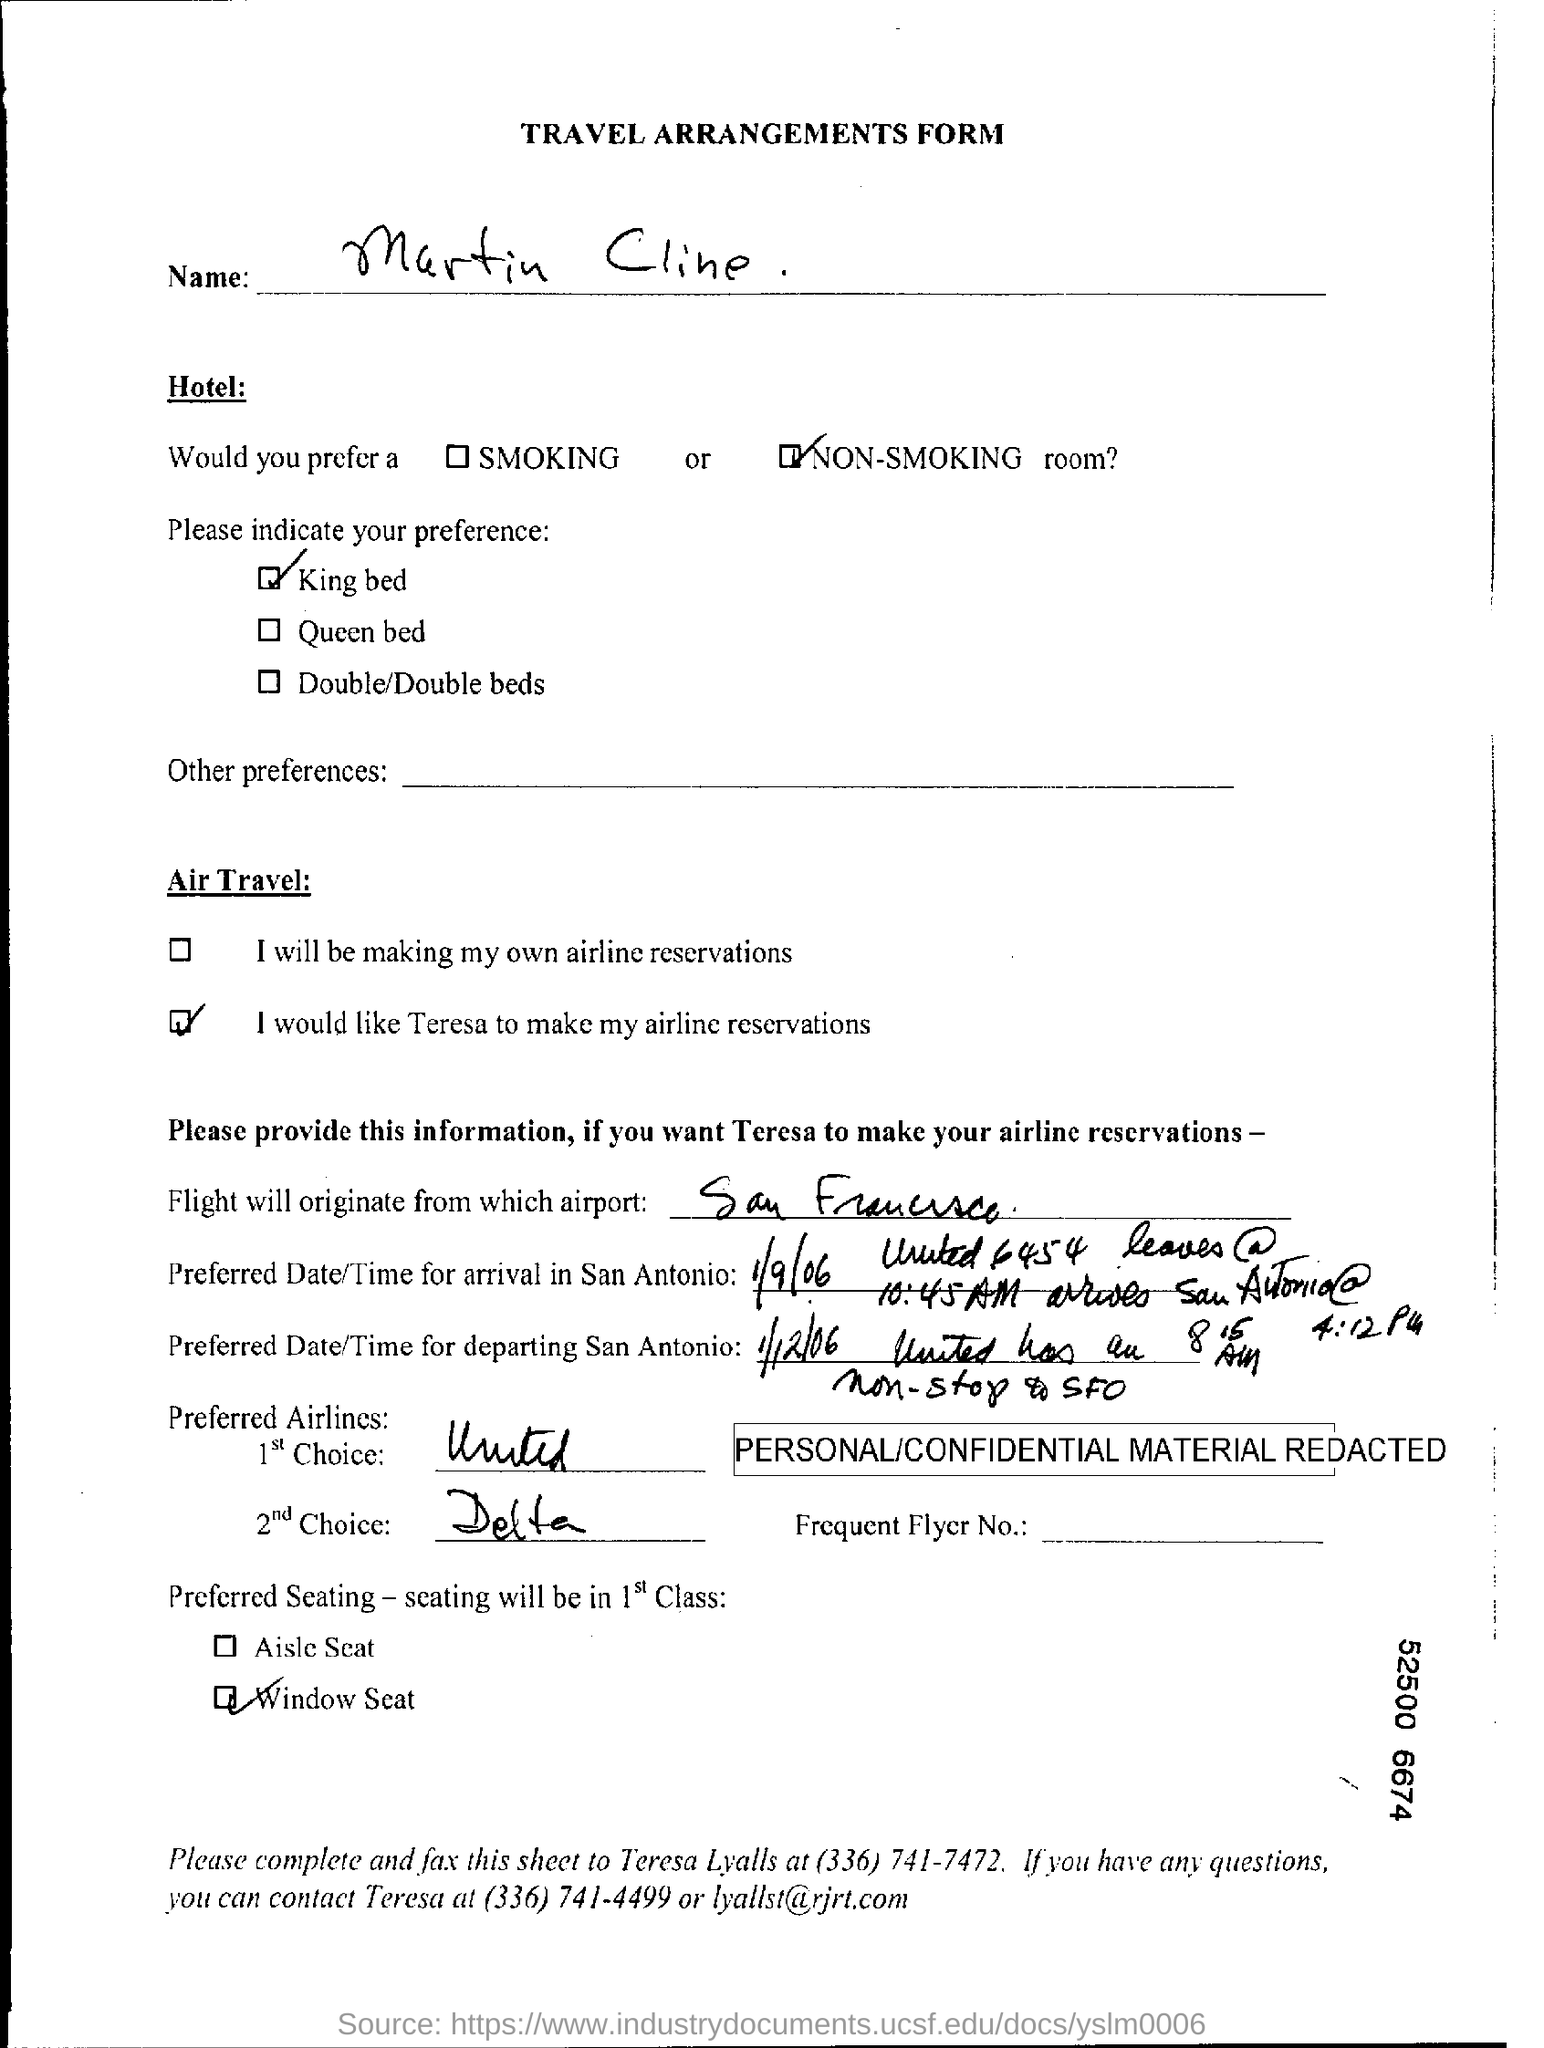The Flight will originate from which airport?
Provide a succinct answer. San Francisco. What type of hotel would you prefer?
Ensure brevity in your answer.  Non-Smoking. What is the preferred seating in 1st class?
Provide a short and direct response. Window Seat. The type of  bed that is preferred?
Provide a succinct answer. King bed. What is the second choice in the preferred airways?
Keep it short and to the point. Delta. 